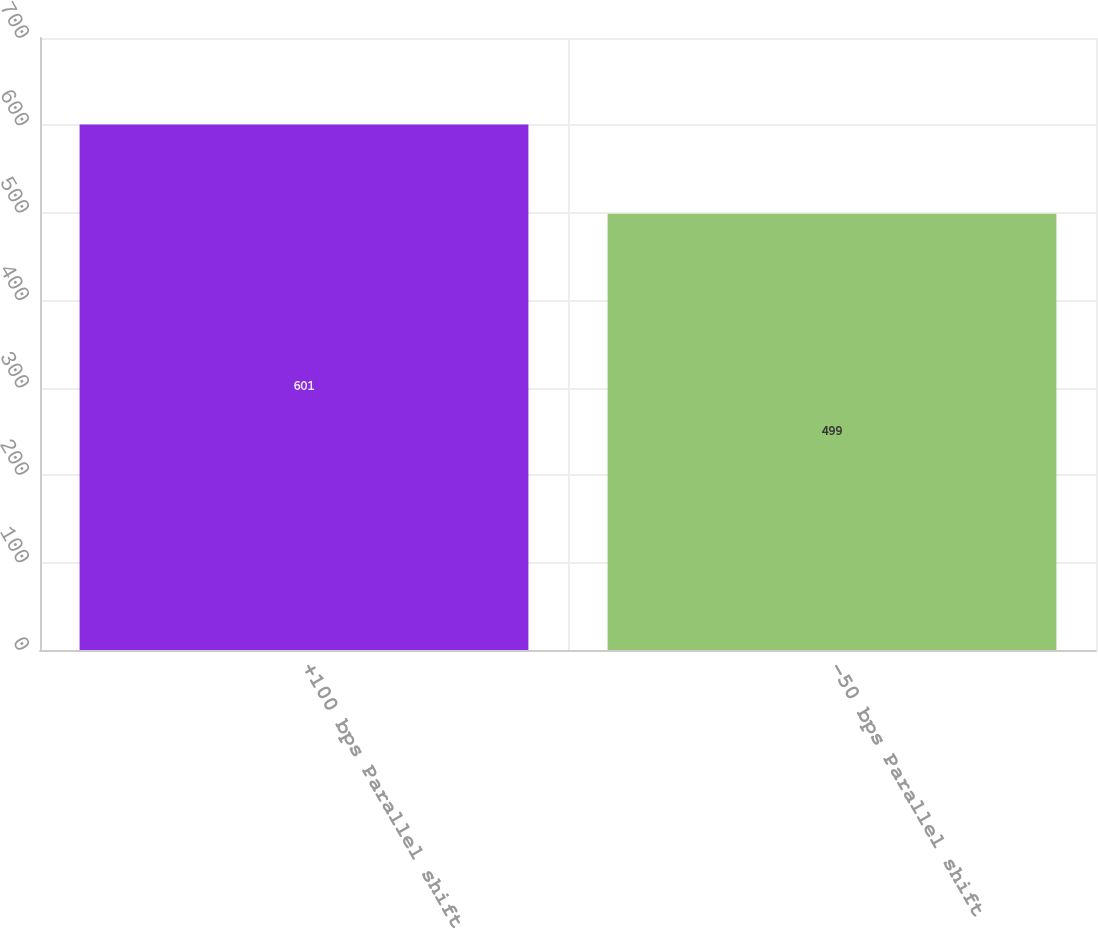Convert chart. <chart><loc_0><loc_0><loc_500><loc_500><bar_chart><fcel>+100 bps Parallel shift<fcel>-50 bps Parallel shift<nl><fcel>601<fcel>499<nl></chart> 